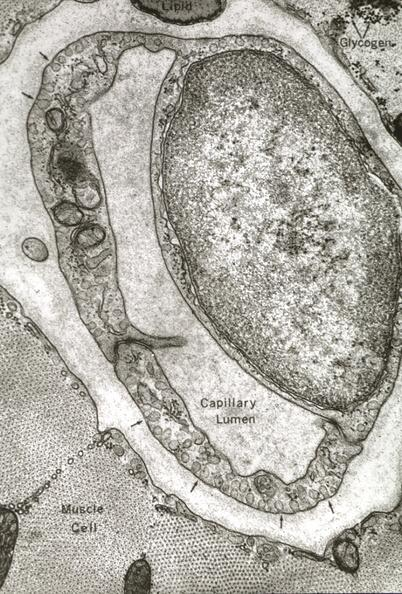s adenocarcinoma present?
Answer the question using a single word or phrase. No 